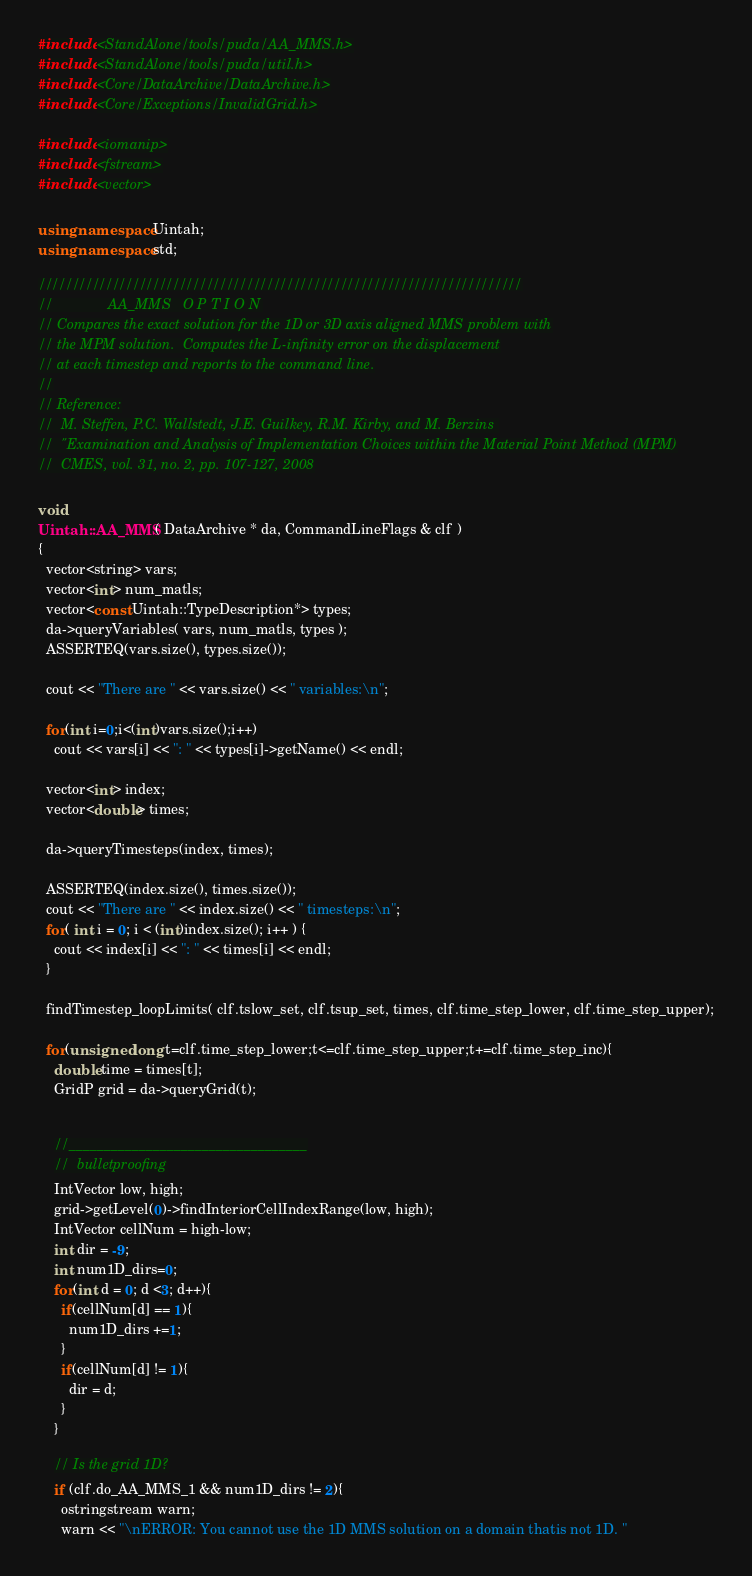Convert code to text. <code><loc_0><loc_0><loc_500><loc_500><_C++_>
#include <StandAlone/tools/puda/AA_MMS.h>
#include <StandAlone/tools/puda/util.h>
#include <Core/DataArchive/DataArchive.h>
#include <Core/Exceptions/InvalidGrid.h>

#include <iomanip>
#include <fstream>
#include <vector>

using namespace Uintah;
using namespace std;

////////////////////////////////////////////////////////////////////////
//              AA_MMS   O P T I O N
// Compares the exact solution for the 1D or 3D axis aligned MMS problem with
// the MPM solution.  Computes the L-infinity error on the displacement
// at each timestep and reports to the command line.
//
// Reference:
//  M. Steffen, P.C. Wallstedt, J.E. Guilkey, R.M. Kirby, and M. Berzins 
//  "Examination and Analysis of Implementation Choices within the Material Point Method (MPM)
//  CMES, vol. 31, no. 2, pp. 107-127, 2008

void
Uintah::AA_MMS( DataArchive * da, CommandLineFlags & clf )
{
  vector<string> vars;
  vector<int> num_matls;
  vector<const Uintah::TypeDescription*> types;
  da->queryVariables( vars, num_matls, types );
  ASSERTEQ(vars.size(), types.size());
  
  cout << "There are " << vars.size() << " variables:\n";
  
  for(int i=0;i<(int)vars.size();i++)
    cout << vars[i] << ": " << types[i]->getName() << endl;
      
  vector<int> index;
  vector<double> times;
  
  da->queryTimesteps(index, times);
  
  ASSERTEQ(index.size(), times.size());
  cout << "There are " << index.size() << " timesteps:\n";
  for( int i = 0; i < (int)index.size(); i++ ) {
    cout << index[i] << ": " << times[i] << endl;
  }
      
  findTimestep_loopLimits( clf.tslow_set, clf.tsup_set, times, clf.time_step_lower, clf.time_step_upper);
      
  for(unsigned long t=clf.time_step_lower;t<=clf.time_step_upper;t+=clf.time_step_inc){
    double time = times[t];
    GridP grid = da->queryGrid(t);
    
    
    //__________________________________
    //  bulletproofing
    IntVector low, high;
    grid->getLevel(0)->findInteriorCellIndexRange(low, high);
    IntVector cellNum = high-low;
    int dir = -9;
    int num1D_dirs=0;
    for(int d = 0; d <3; d++){
      if(cellNum[d] == 1){
        num1D_dirs +=1;
      }
      if(cellNum[d] != 1){
        dir = d;
      }
    }
    
    // Is the grid 1D?
    if (clf.do_AA_MMS_1 && num1D_dirs != 2){
      ostringstream warn;
      warn << "\nERROR: You cannot use the 1D MMS solution on a domain thatis not 1D. "</code> 